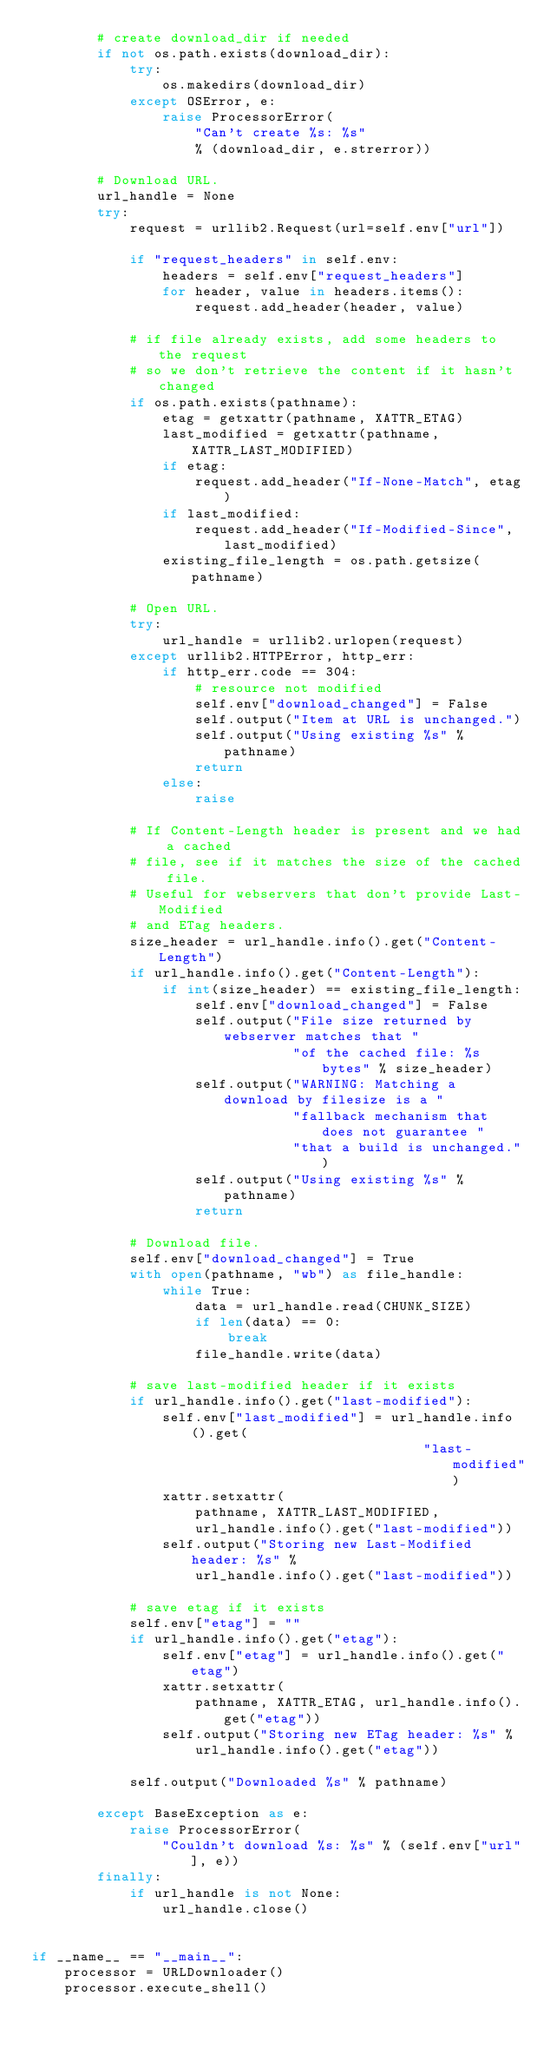<code> <loc_0><loc_0><loc_500><loc_500><_Python_>        # create download_dir if needed
        if not os.path.exists(download_dir):
            try:
                os.makedirs(download_dir)
            except OSError, e:
                raise ProcessorError(
                    "Can't create %s: %s" 
                    % (download_dir, e.strerror))
        
        # Download URL.
        url_handle = None
        try:
            request = urllib2.Request(url=self.env["url"])
            
            if "request_headers" in self.env:
                headers = self.env["request_headers"]
                for header, value in headers.items():
                    request.add_header(header, value)
                    
            # if file already exists, add some headers to the request
            # so we don't retrieve the content if it hasn't changed
            if os.path.exists(pathname):
                etag = getxattr(pathname, XATTR_ETAG)
                last_modified = getxattr(pathname, XATTR_LAST_MODIFIED)
                if etag:
                    request.add_header("If-None-Match", etag)
                if last_modified:
                    request.add_header("If-Modified-Since", last_modified)
                existing_file_length = os.path.getsize(pathname)
                    
            # Open URL.
            try:
                url_handle = urllib2.urlopen(request)
            except urllib2.HTTPError, http_err:
                if http_err.code == 304:
                    # resource not modified
                    self.env["download_changed"] = False
                    self.output("Item at URL is unchanged.")
                    self.output("Using existing %s" % pathname)
                    return
                else:
                    raise
            
            # If Content-Length header is present and we had a cached
            # file, see if it matches the size of the cached file.
            # Useful for webservers that don't provide Last-Modified
            # and ETag headers.
            size_header = url_handle.info().get("Content-Length")
            if url_handle.info().get("Content-Length"):
                if int(size_header) == existing_file_length:
                    self.env["download_changed"] = False
                    self.output("File size returned by webserver matches that "
                                "of the cached file: %s bytes" % size_header)
                    self.output("WARNING: Matching a download by filesize is a "
                                "fallback mechanism that does not guarantee "
                                "that a build is unchanged.")
                    self.output("Using existing %s" % pathname)
                    return

            # Download file.
            self.env["download_changed"] = True
            with open(pathname, "wb") as file_handle:
                while True:
                    data = url_handle.read(CHUNK_SIZE)
                    if len(data) == 0:
                        break
                    file_handle.write(data)
                    
            # save last-modified header if it exists
            if url_handle.info().get("last-modified"):
                self.env["last_modified"] = url_handle.info().get(
                                                "last-modified")
                xattr.setxattr(
                    pathname, XATTR_LAST_MODIFIED,
                    url_handle.info().get("last-modified"))
                self.output("Storing new Last-Modified header: %s" %
                    url_handle.info().get("last-modified"))
                            
            # save etag if it exists
            self.env["etag"] = ""
            if url_handle.info().get("etag"):
                self.env["etag"] = url_handle.info().get("etag")
                xattr.setxattr(
                    pathname, XATTR_ETAG, url_handle.info().get("etag"))
                self.output("Storing new ETag header: %s" %
                    url_handle.info().get("etag"))
                    
            self.output("Downloaded %s" % pathname)
        
        except BaseException as e:
            raise ProcessorError(
                "Couldn't download %s: %s" % (self.env["url"], e))
        finally:
            if url_handle is not None:
                url_handle.close()


if __name__ == "__main__":
    processor = URLDownloader()
    processor.execute_shell()
    
</code> 